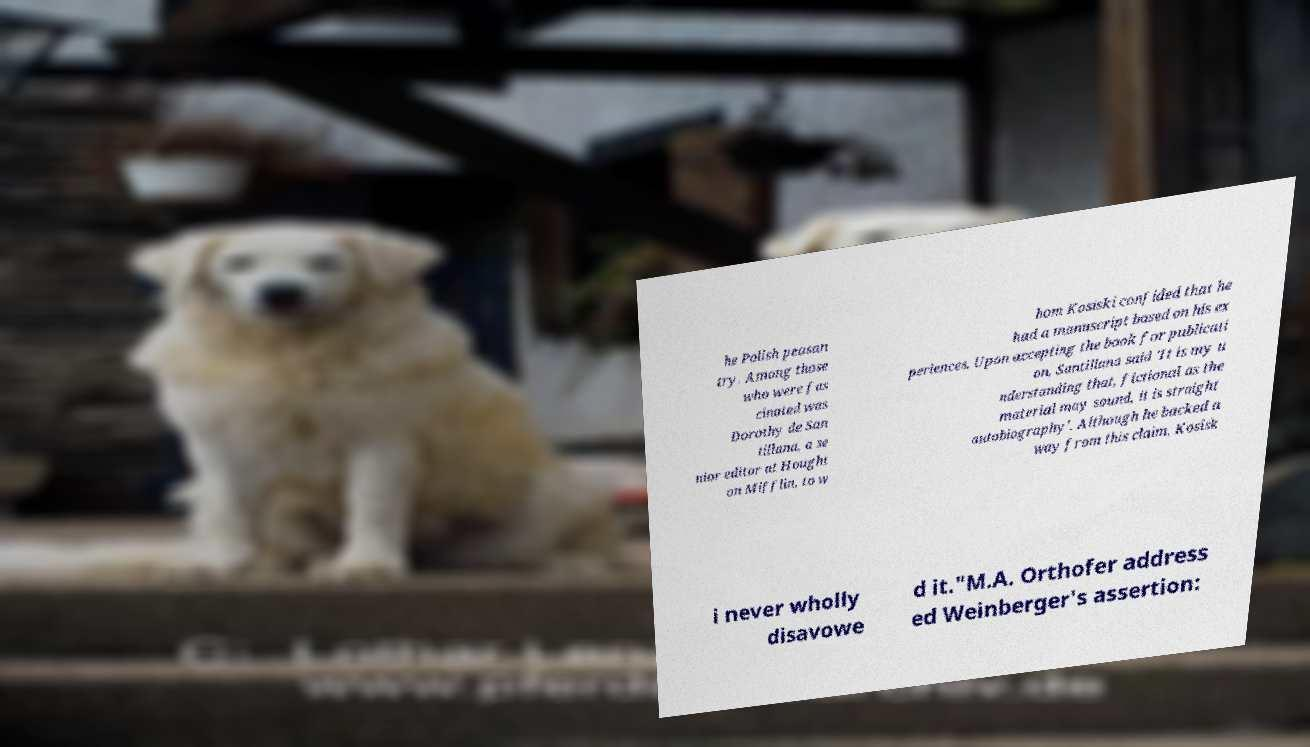Could you assist in decoding the text presented in this image and type it out clearly? he Polish peasan try. Among those who were fas cinated was Dorothy de San tillana, a se nior editor at Hought on Mifflin, to w hom Kosiski confided that he had a manuscript based on his ex periences. Upon accepting the book for publicati on, Santillana said 'It is my u nderstanding that, fictional as the material may sound, it is straight autobiography'. Although he backed a way from this claim, Kosisk i never wholly disavowe d it."M.A. Orthofer address ed Weinberger's assertion: 